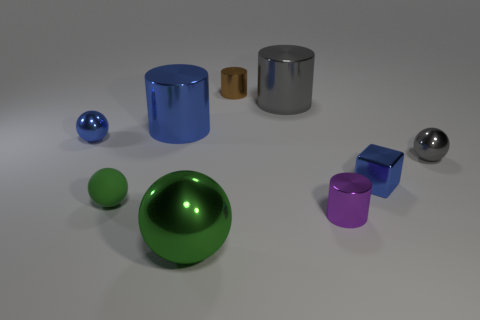Are there any other things that are made of the same material as the tiny green object?
Your response must be concise. No. Is the number of blue shiny cubes in front of the tiny blue shiny block greater than the number of purple metal objects that are to the right of the tiny brown cylinder?
Provide a succinct answer. No. There is a large cylinder that is in front of the large gray shiny object; does it have the same color as the tiny cylinder that is in front of the small brown shiny object?
Give a very brief answer. No. There is a green sphere that is behind the small metal cylinder that is in front of the blue thing to the left of the large blue shiny cylinder; what size is it?
Your answer should be very brief. Small. There is another small object that is the same shape as the purple object; what color is it?
Provide a succinct answer. Brown. Is the number of tiny gray metallic things on the right side of the small gray metal ball greater than the number of gray cubes?
Your answer should be very brief. No. There is a big gray metallic object; is its shape the same as the shiny thing that is in front of the tiny purple cylinder?
Your answer should be compact. No. Is there anything else that is the same size as the gray shiny cylinder?
Ensure brevity in your answer.  Yes. What is the size of the blue metallic thing that is the same shape as the purple shiny thing?
Keep it short and to the point. Large. Are there more large purple objects than purple things?
Offer a very short reply. No. 